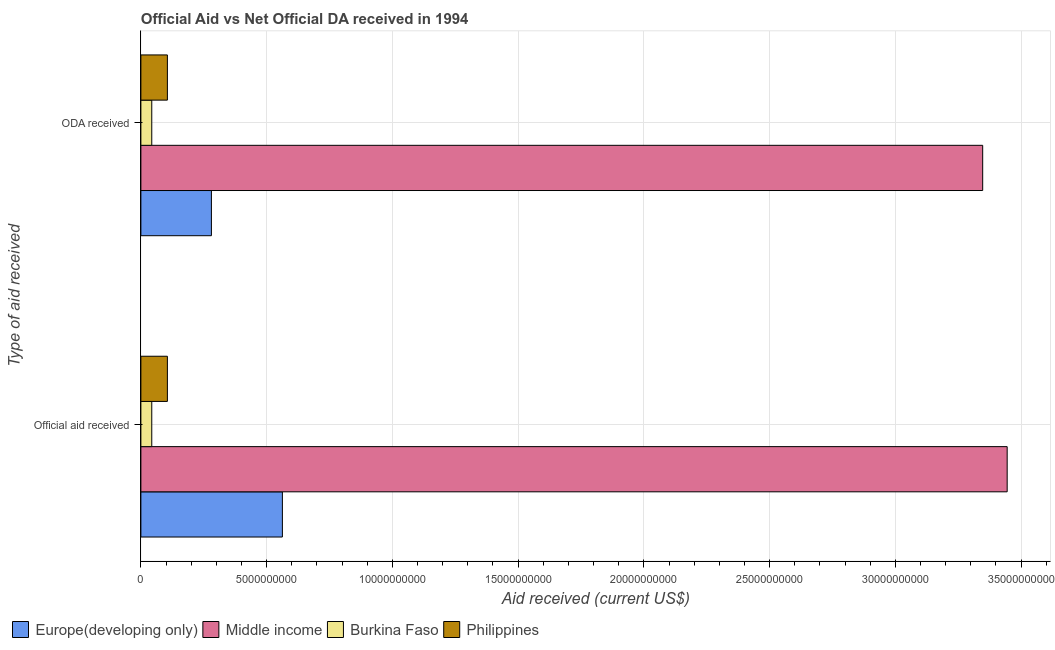How many groups of bars are there?
Offer a terse response. 2. Are the number of bars per tick equal to the number of legend labels?
Provide a short and direct response. Yes. Are the number of bars on each tick of the Y-axis equal?
Your answer should be very brief. Yes. How many bars are there on the 2nd tick from the top?
Your answer should be very brief. 4. How many bars are there on the 1st tick from the bottom?
Offer a terse response. 4. What is the label of the 2nd group of bars from the top?
Your answer should be compact. Official aid received. What is the official aid received in Europe(developing only)?
Your answer should be very brief. 5.63e+09. Across all countries, what is the maximum official aid received?
Offer a very short reply. 3.44e+1. Across all countries, what is the minimum oda received?
Provide a short and direct response. 4.33e+08. In which country was the oda received minimum?
Provide a short and direct response. Burkina Faso. What is the total oda received in the graph?
Provide a short and direct response. 3.78e+1. What is the difference between the oda received in Europe(developing only) and that in Burkina Faso?
Make the answer very short. 2.37e+09. What is the difference between the oda received in Philippines and the official aid received in Europe(developing only)?
Make the answer very short. -4.57e+09. What is the average oda received per country?
Offer a terse response. 9.44e+09. What is the difference between the oda received and official aid received in Middle income?
Give a very brief answer. -9.74e+08. In how many countries, is the official aid received greater than 19000000000 US$?
Offer a terse response. 1. What is the ratio of the oda received in Philippines to that in Europe(developing only)?
Offer a very short reply. 0.38. What does the 3rd bar from the top in Official aid received represents?
Provide a succinct answer. Middle income. What does the 1st bar from the bottom in ODA received represents?
Keep it short and to the point. Europe(developing only). How many bars are there?
Your response must be concise. 8. How many countries are there in the graph?
Your answer should be very brief. 4. Are the values on the major ticks of X-axis written in scientific E-notation?
Provide a short and direct response. No. How many legend labels are there?
Your answer should be compact. 4. What is the title of the graph?
Offer a terse response. Official Aid vs Net Official DA received in 1994 . Does "Portugal" appear as one of the legend labels in the graph?
Give a very brief answer. No. What is the label or title of the X-axis?
Ensure brevity in your answer.  Aid received (current US$). What is the label or title of the Y-axis?
Offer a very short reply. Type of aid received. What is the Aid received (current US$) in Europe(developing only) in Official aid received?
Your response must be concise. 5.63e+09. What is the Aid received (current US$) in Middle income in Official aid received?
Your response must be concise. 3.44e+1. What is the Aid received (current US$) of Burkina Faso in Official aid received?
Your response must be concise. 4.33e+08. What is the Aid received (current US$) of Philippines in Official aid received?
Give a very brief answer. 1.05e+09. What is the Aid received (current US$) in Europe(developing only) in ODA received?
Your answer should be very brief. 2.80e+09. What is the Aid received (current US$) in Middle income in ODA received?
Provide a short and direct response. 3.35e+1. What is the Aid received (current US$) in Burkina Faso in ODA received?
Offer a terse response. 4.33e+08. What is the Aid received (current US$) of Philippines in ODA received?
Your answer should be compact. 1.05e+09. Across all Type of aid received, what is the maximum Aid received (current US$) of Europe(developing only)?
Keep it short and to the point. 5.63e+09. Across all Type of aid received, what is the maximum Aid received (current US$) of Middle income?
Your answer should be compact. 3.44e+1. Across all Type of aid received, what is the maximum Aid received (current US$) of Burkina Faso?
Your response must be concise. 4.33e+08. Across all Type of aid received, what is the maximum Aid received (current US$) in Philippines?
Ensure brevity in your answer.  1.05e+09. Across all Type of aid received, what is the minimum Aid received (current US$) in Europe(developing only)?
Offer a terse response. 2.80e+09. Across all Type of aid received, what is the minimum Aid received (current US$) in Middle income?
Make the answer very short. 3.35e+1. Across all Type of aid received, what is the minimum Aid received (current US$) in Burkina Faso?
Make the answer very short. 4.33e+08. Across all Type of aid received, what is the minimum Aid received (current US$) of Philippines?
Provide a succinct answer. 1.05e+09. What is the total Aid received (current US$) in Europe(developing only) in the graph?
Your response must be concise. 8.43e+09. What is the total Aid received (current US$) in Middle income in the graph?
Your response must be concise. 6.79e+1. What is the total Aid received (current US$) of Burkina Faso in the graph?
Offer a terse response. 8.65e+08. What is the total Aid received (current US$) of Philippines in the graph?
Your answer should be compact. 2.11e+09. What is the difference between the Aid received (current US$) in Europe(developing only) in Official aid received and that in ODA received?
Provide a short and direct response. 2.82e+09. What is the difference between the Aid received (current US$) in Middle income in Official aid received and that in ODA received?
Ensure brevity in your answer.  9.74e+08. What is the difference between the Aid received (current US$) of Europe(developing only) in Official aid received and the Aid received (current US$) of Middle income in ODA received?
Offer a terse response. -2.78e+1. What is the difference between the Aid received (current US$) of Europe(developing only) in Official aid received and the Aid received (current US$) of Burkina Faso in ODA received?
Provide a succinct answer. 5.19e+09. What is the difference between the Aid received (current US$) of Europe(developing only) in Official aid received and the Aid received (current US$) of Philippines in ODA received?
Provide a succinct answer. 4.57e+09. What is the difference between the Aid received (current US$) in Middle income in Official aid received and the Aid received (current US$) in Burkina Faso in ODA received?
Keep it short and to the point. 3.40e+1. What is the difference between the Aid received (current US$) of Middle income in Official aid received and the Aid received (current US$) of Philippines in ODA received?
Your response must be concise. 3.34e+1. What is the difference between the Aid received (current US$) in Burkina Faso in Official aid received and the Aid received (current US$) in Philippines in ODA received?
Offer a terse response. -6.21e+08. What is the average Aid received (current US$) in Europe(developing only) per Type of aid received?
Ensure brevity in your answer.  4.22e+09. What is the average Aid received (current US$) in Middle income per Type of aid received?
Your answer should be very brief. 3.40e+1. What is the average Aid received (current US$) in Burkina Faso per Type of aid received?
Offer a very short reply. 4.33e+08. What is the average Aid received (current US$) in Philippines per Type of aid received?
Offer a very short reply. 1.05e+09. What is the difference between the Aid received (current US$) of Europe(developing only) and Aid received (current US$) of Middle income in Official aid received?
Your answer should be compact. -2.88e+1. What is the difference between the Aid received (current US$) in Europe(developing only) and Aid received (current US$) in Burkina Faso in Official aid received?
Your answer should be very brief. 5.19e+09. What is the difference between the Aid received (current US$) in Europe(developing only) and Aid received (current US$) in Philippines in Official aid received?
Make the answer very short. 4.57e+09. What is the difference between the Aid received (current US$) of Middle income and Aid received (current US$) of Burkina Faso in Official aid received?
Offer a terse response. 3.40e+1. What is the difference between the Aid received (current US$) in Middle income and Aid received (current US$) in Philippines in Official aid received?
Make the answer very short. 3.34e+1. What is the difference between the Aid received (current US$) in Burkina Faso and Aid received (current US$) in Philippines in Official aid received?
Your answer should be compact. -6.21e+08. What is the difference between the Aid received (current US$) in Europe(developing only) and Aid received (current US$) in Middle income in ODA received?
Your response must be concise. -3.07e+1. What is the difference between the Aid received (current US$) in Europe(developing only) and Aid received (current US$) in Burkina Faso in ODA received?
Provide a succinct answer. 2.37e+09. What is the difference between the Aid received (current US$) of Europe(developing only) and Aid received (current US$) of Philippines in ODA received?
Your answer should be very brief. 1.75e+09. What is the difference between the Aid received (current US$) in Middle income and Aid received (current US$) in Burkina Faso in ODA received?
Your response must be concise. 3.30e+1. What is the difference between the Aid received (current US$) in Middle income and Aid received (current US$) in Philippines in ODA received?
Ensure brevity in your answer.  3.24e+1. What is the difference between the Aid received (current US$) of Burkina Faso and Aid received (current US$) of Philippines in ODA received?
Make the answer very short. -6.21e+08. What is the ratio of the Aid received (current US$) of Europe(developing only) in Official aid received to that in ODA received?
Offer a terse response. 2.01. What is the ratio of the Aid received (current US$) in Middle income in Official aid received to that in ODA received?
Your answer should be very brief. 1.03. What is the ratio of the Aid received (current US$) in Burkina Faso in Official aid received to that in ODA received?
Your response must be concise. 1. What is the difference between the highest and the second highest Aid received (current US$) of Europe(developing only)?
Offer a terse response. 2.82e+09. What is the difference between the highest and the second highest Aid received (current US$) of Middle income?
Provide a succinct answer. 9.74e+08. What is the difference between the highest and the second highest Aid received (current US$) of Philippines?
Provide a succinct answer. 0. What is the difference between the highest and the lowest Aid received (current US$) of Europe(developing only)?
Your answer should be compact. 2.82e+09. What is the difference between the highest and the lowest Aid received (current US$) of Middle income?
Ensure brevity in your answer.  9.74e+08. What is the difference between the highest and the lowest Aid received (current US$) in Burkina Faso?
Your answer should be compact. 0. What is the difference between the highest and the lowest Aid received (current US$) in Philippines?
Make the answer very short. 0. 